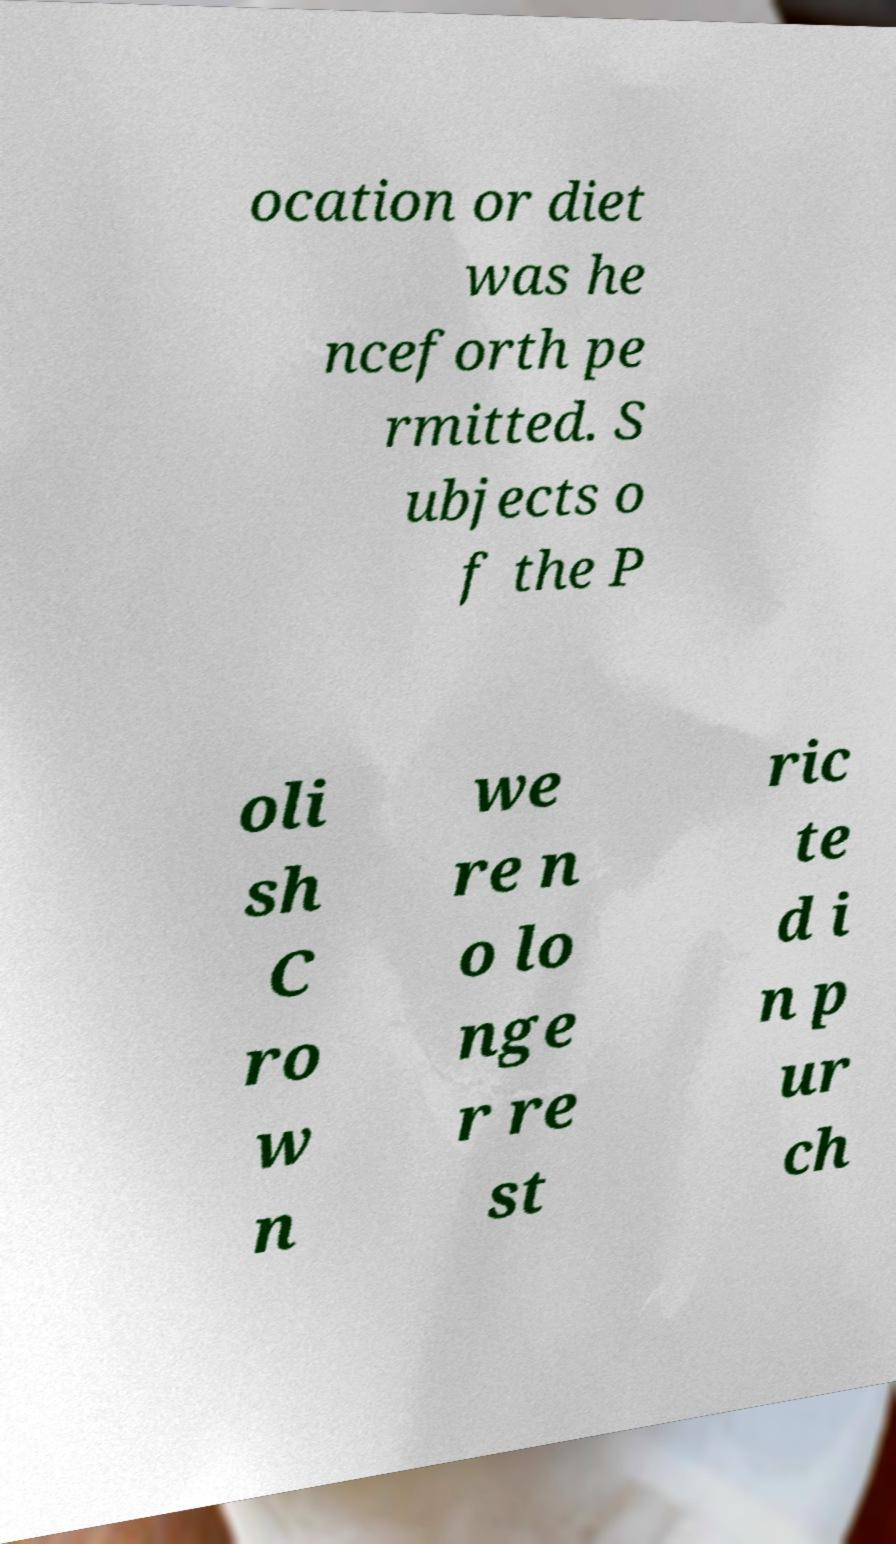Could you extract and type out the text from this image? ocation or diet was he nceforth pe rmitted. S ubjects o f the P oli sh C ro w n we re n o lo nge r re st ric te d i n p ur ch 